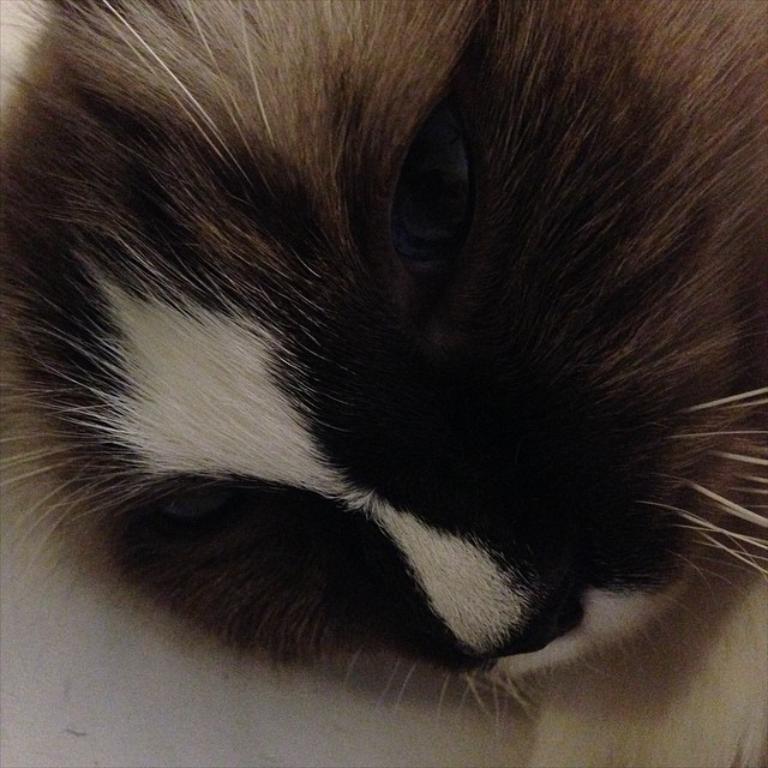Could you give a brief overview of what you see in this image? It is a zoomed in picture of a cat. 